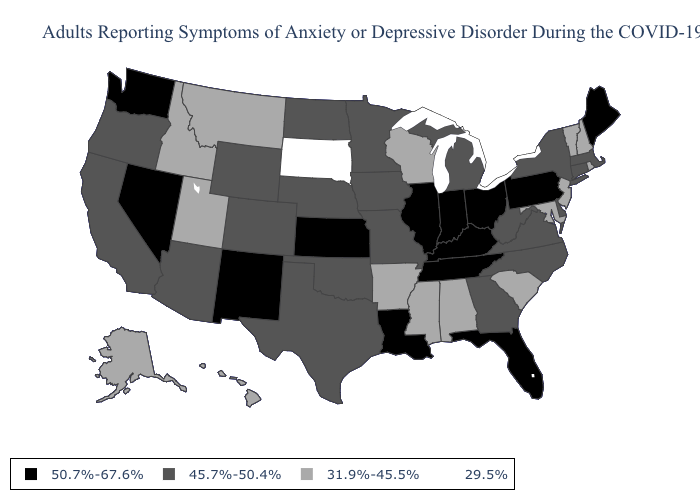Name the states that have a value in the range 50.7%-67.6%?
Give a very brief answer. Florida, Illinois, Indiana, Kansas, Kentucky, Louisiana, Maine, Nevada, New Mexico, Ohio, Pennsylvania, Tennessee, Washington. Name the states that have a value in the range 50.7%-67.6%?
Concise answer only. Florida, Illinois, Indiana, Kansas, Kentucky, Louisiana, Maine, Nevada, New Mexico, Ohio, Pennsylvania, Tennessee, Washington. Which states have the lowest value in the USA?
Answer briefly. South Dakota. Name the states that have a value in the range 45.7%-50.4%?
Short answer required. Arizona, California, Colorado, Connecticut, Delaware, Georgia, Iowa, Massachusetts, Michigan, Minnesota, Missouri, Nebraska, New York, North Carolina, North Dakota, Oklahoma, Oregon, Texas, Virginia, West Virginia, Wyoming. How many symbols are there in the legend?
Short answer required. 4. Does West Virginia have a higher value than Illinois?
Concise answer only. No. Does New Jersey have the lowest value in the Northeast?
Quick response, please. Yes. Does South Dakota have the lowest value in the MidWest?
Be succinct. Yes. Does Ohio have the same value as Washington?
Be succinct. Yes. Name the states that have a value in the range 50.7%-67.6%?
Quick response, please. Florida, Illinois, Indiana, Kansas, Kentucky, Louisiana, Maine, Nevada, New Mexico, Ohio, Pennsylvania, Tennessee, Washington. Does Louisiana have the lowest value in the USA?
Keep it brief. No. What is the value of Alaska?
Quick response, please. 31.9%-45.5%. Name the states that have a value in the range 45.7%-50.4%?
Short answer required. Arizona, California, Colorado, Connecticut, Delaware, Georgia, Iowa, Massachusetts, Michigan, Minnesota, Missouri, Nebraska, New York, North Carolina, North Dakota, Oklahoma, Oregon, Texas, Virginia, West Virginia, Wyoming. Name the states that have a value in the range 45.7%-50.4%?
Be succinct. Arizona, California, Colorado, Connecticut, Delaware, Georgia, Iowa, Massachusetts, Michigan, Minnesota, Missouri, Nebraska, New York, North Carolina, North Dakota, Oklahoma, Oregon, Texas, Virginia, West Virginia, Wyoming. 